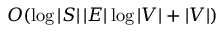Convert formula to latex. <formula><loc_0><loc_0><loc_500><loc_500>O ( \log | S | \, | E | \log | V | + | V | )</formula> 